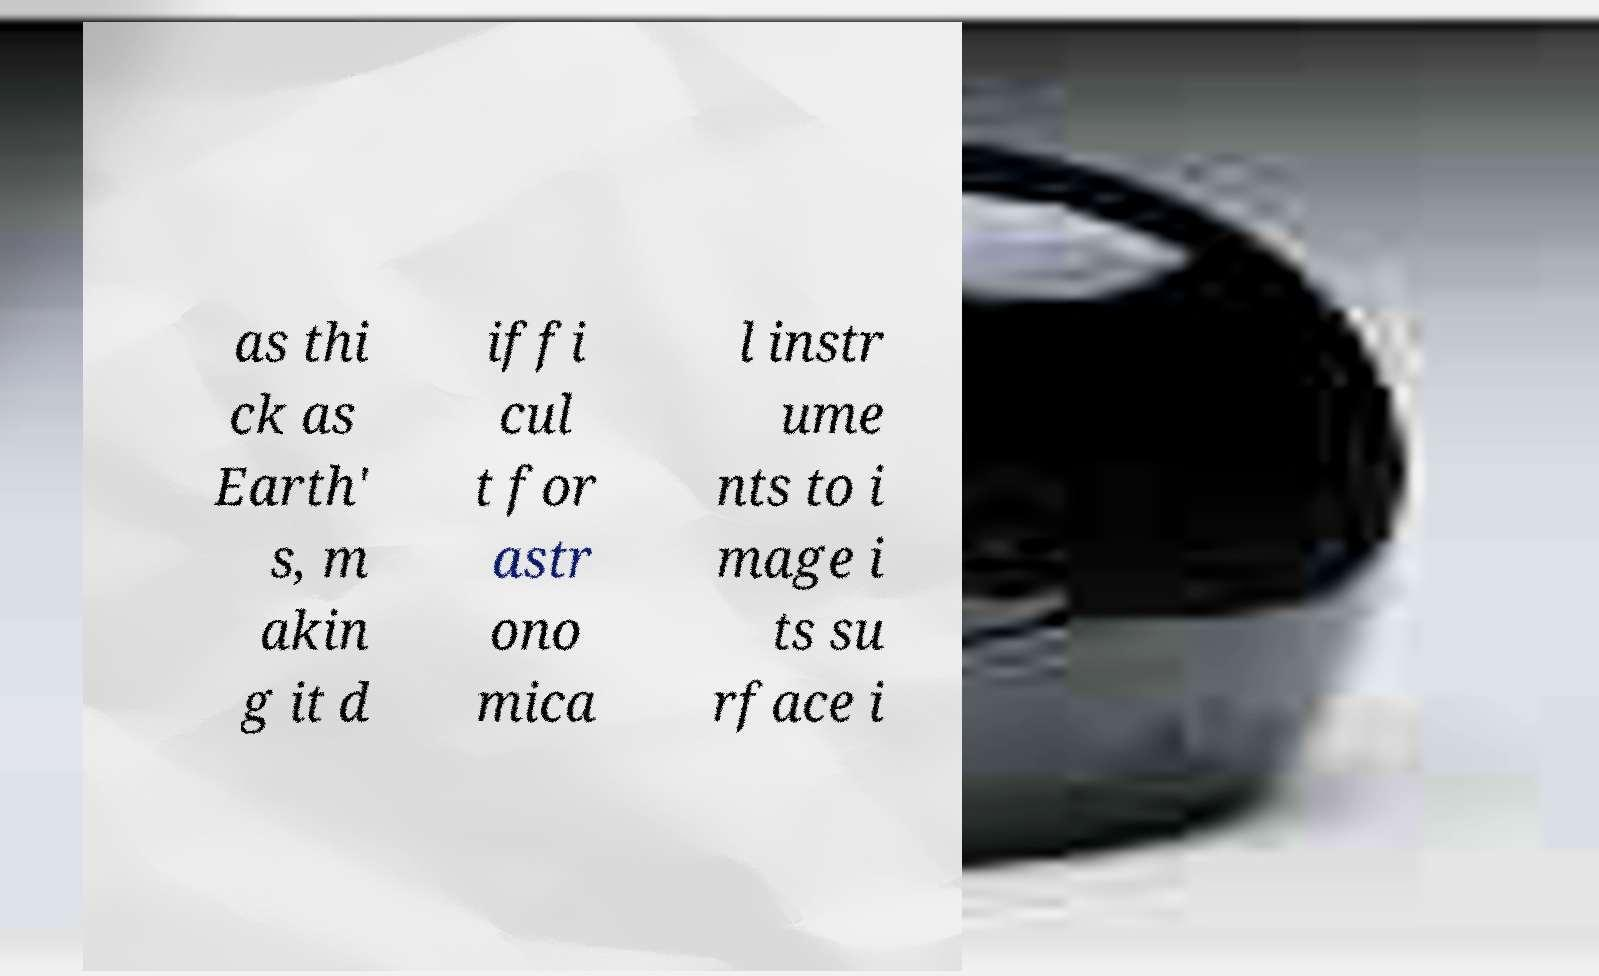For documentation purposes, I need the text within this image transcribed. Could you provide that? as thi ck as Earth' s, m akin g it d iffi cul t for astr ono mica l instr ume nts to i mage i ts su rface i 